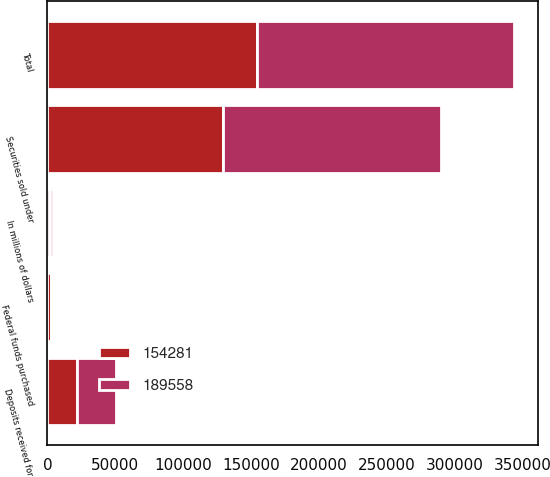Convert chart. <chart><loc_0><loc_0><loc_500><loc_500><stacked_bar_chart><ecel><fcel>In millions of dollars<fcel>Federal funds purchased<fcel>Securities sold under<fcel>Deposits received for<fcel>Total<nl><fcel>189558<fcel>2010<fcel>478<fcel>160598<fcel>28482<fcel>189558<nl><fcel>154281<fcel>2009<fcel>2877<fcel>129656<fcel>21748<fcel>154281<nl></chart> 